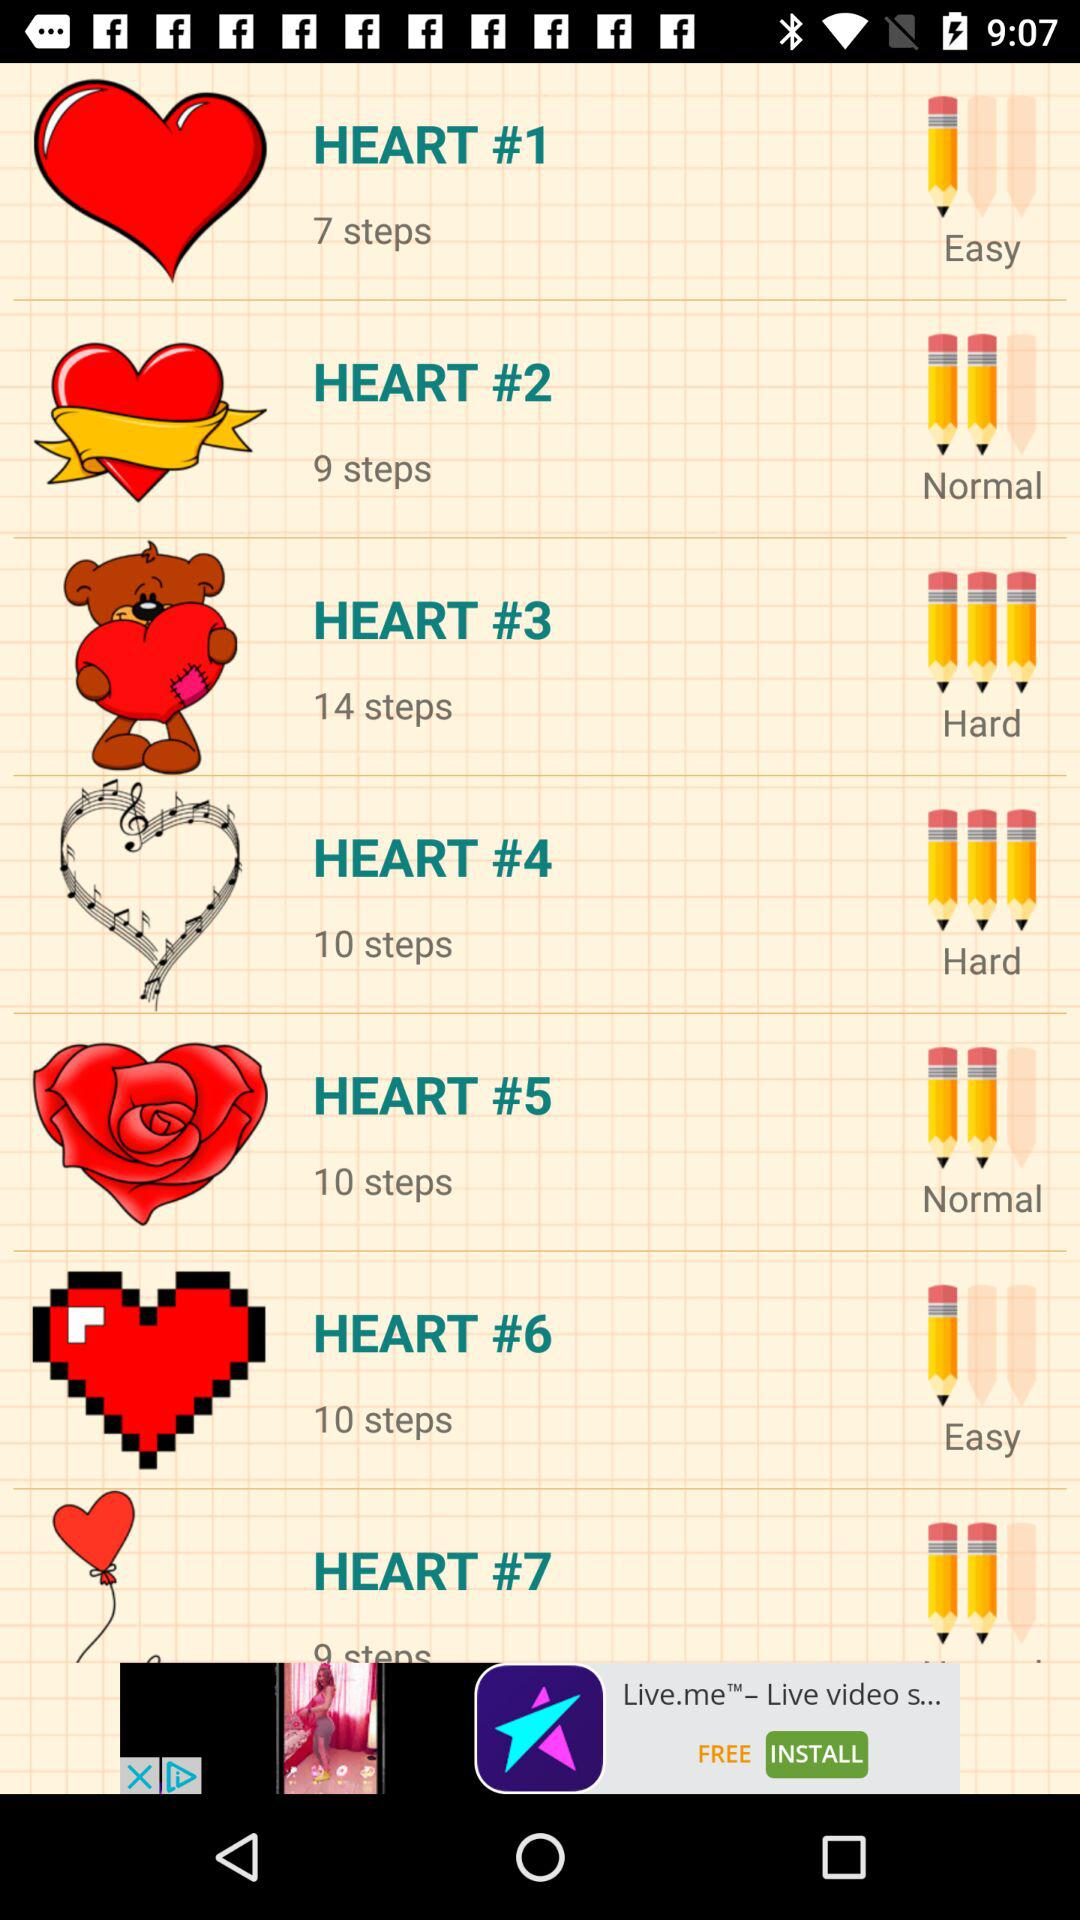How many steps are there in "HEART #1"? There are 7 steps. 